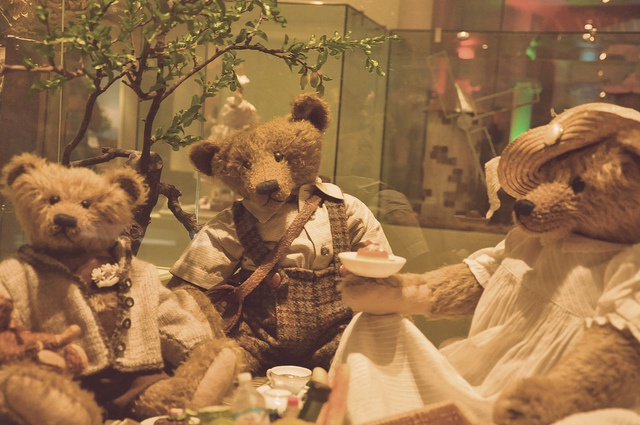Describe the objects in this image and their specific colors. I can see teddy bear in brown and tan tones, teddy bear in brown, tan, gray, and maroon tones, teddy bear in brown, maroon, and gray tones, handbag in brown and maroon tones, and bottle in brown, tan, and olive tones in this image. 